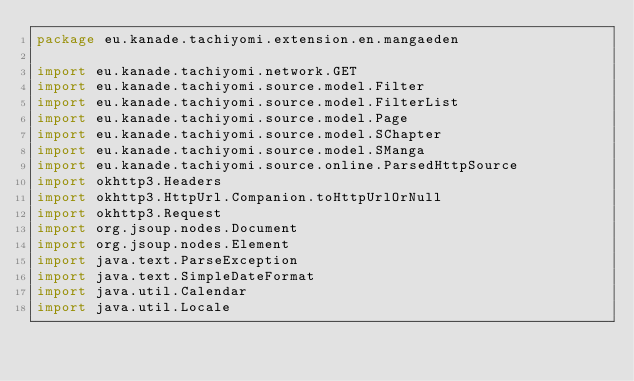<code> <loc_0><loc_0><loc_500><loc_500><_Kotlin_>package eu.kanade.tachiyomi.extension.en.mangaeden

import eu.kanade.tachiyomi.network.GET
import eu.kanade.tachiyomi.source.model.Filter
import eu.kanade.tachiyomi.source.model.FilterList
import eu.kanade.tachiyomi.source.model.Page
import eu.kanade.tachiyomi.source.model.SChapter
import eu.kanade.tachiyomi.source.model.SManga
import eu.kanade.tachiyomi.source.online.ParsedHttpSource
import okhttp3.Headers
import okhttp3.HttpUrl.Companion.toHttpUrlOrNull
import okhttp3.Request
import org.jsoup.nodes.Document
import org.jsoup.nodes.Element
import java.text.ParseException
import java.text.SimpleDateFormat
import java.util.Calendar
import java.util.Locale
</code> 